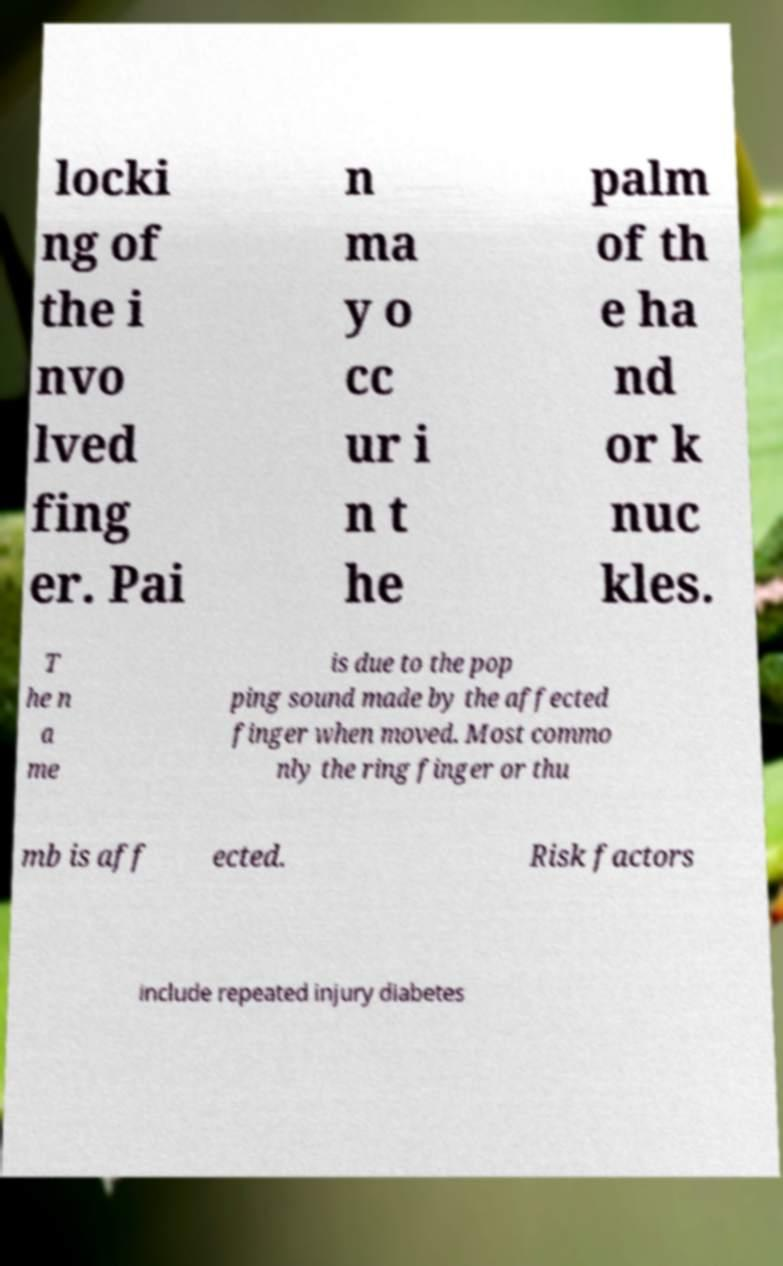Could you extract and type out the text from this image? locki ng of the i nvo lved fing er. Pai n ma y o cc ur i n t he palm of th e ha nd or k nuc kles. T he n a me is due to the pop ping sound made by the affected finger when moved. Most commo nly the ring finger or thu mb is aff ected. Risk factors include repeated injury diabetes 